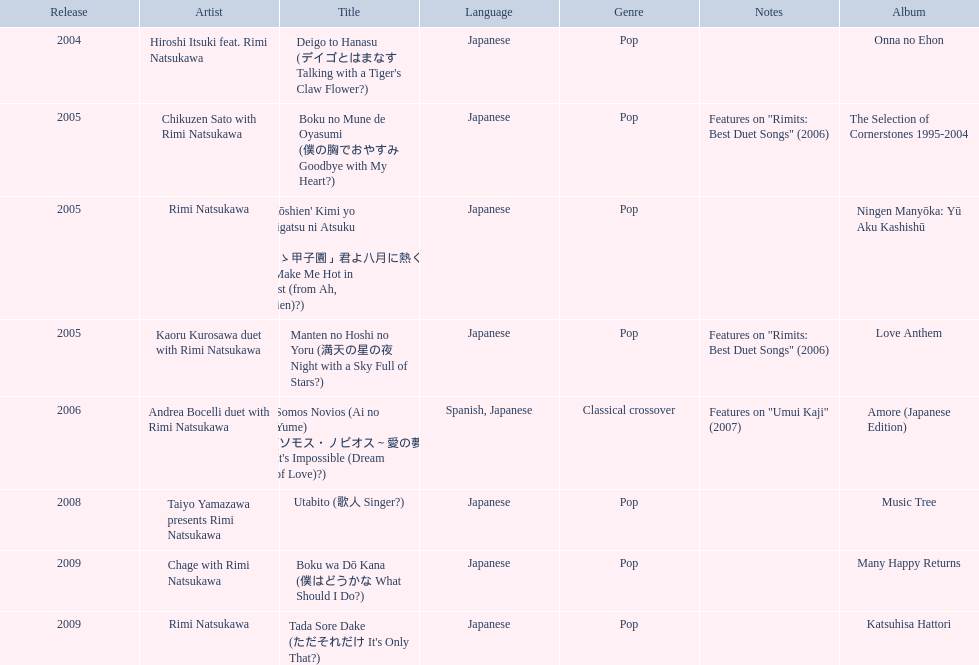When was onna no ehon released? 2004. When was the selection of cornerstones 1995-2004 released? 2005. What was released in 2008? Music Tree. 